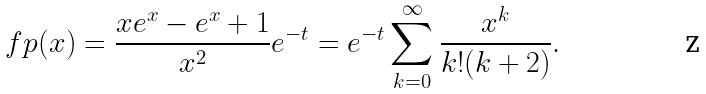Convert formula to latex. <formula><loc_0><loc_0><loc_500><loc_500>\ f p ( x ) = \frac { x e ^ { x } - e ^ { x } + 1 } { x ^ { 2 } } e ^ { - t } = e ^ { - t } \sum _ { k = 0 } ^ { \infty } \frac { x ^ { k } } { k ! ( k + 2 ) } .</formula> 